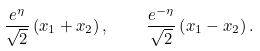Convert formula to latex. <formula><loc_0><loc_0><loc_500><loc_500>\frac { e ^ { \eta } } { \sqrt { 2 } } \left ( x _ { 1 } + x _ { 2 } \right ) , \quad \frac { e ^ { - \eta } } { \sqrt { 2 } } \left ( x _ { 1 } - x _ { 2 } \right ) .</formula> 